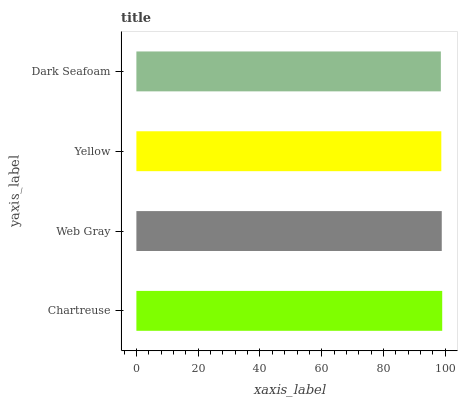Is Dark Seafoam the minimum?
Answer yes or no. Yes. Is Chartreuse the maximum?
Answer yes or no. Yes. Is Web Gray the minimum?
Answer yes or no. No. Is Web Gray the maximum?
Answer yes or no. No. Is Chartreuse greater than Web Gray?
Answer yes or no. Yes. Is Web Gray less than Chartreuse?
Answer yes or no. Yes. Is Web Gray greater than Chartreuse?
Answer yes or no. No. Is Chartreuse less than Web Gray?
Answer yes or no. No. Is Web Gray the high median?
Answer yes or no. Yes. Is Yellow the low median?
Answer yes or no. Yes. Is Dark Seafoam the high median?
Answer yes or no. No. Is Chartreuse the low median?
Answer yes or no. No. 